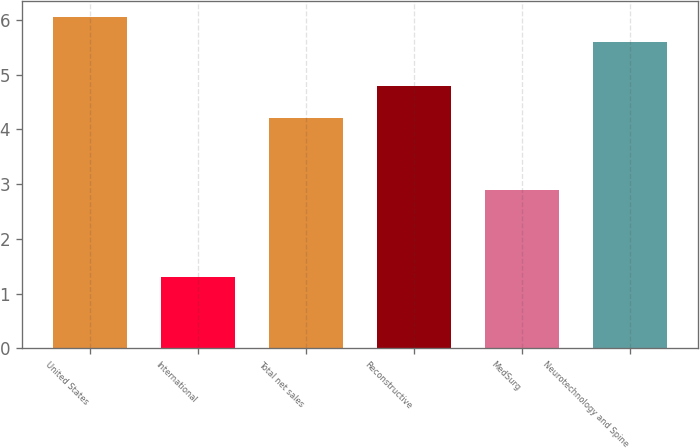<chart> <loc_0><loc_0><loc_500><loc_500><bar_chart><fcel>United States<fcel>International<fcel>Total net sales<fcel>Reconstructive<fcel>MedSurg<fcel>Neurotechnology and Spine<nl><fcel>6.05<fcel>1.3<fcel>4.2<fcel>4.8<fcel>2.9<fcel>5.6<nl></chart> 